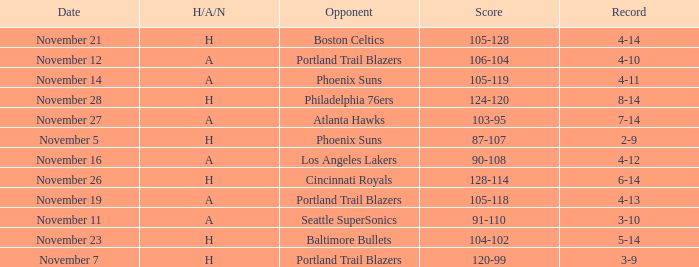What is the Opponent of the game with a H/A/N of H and Score of 120-99? Portland Trail Blazers. 